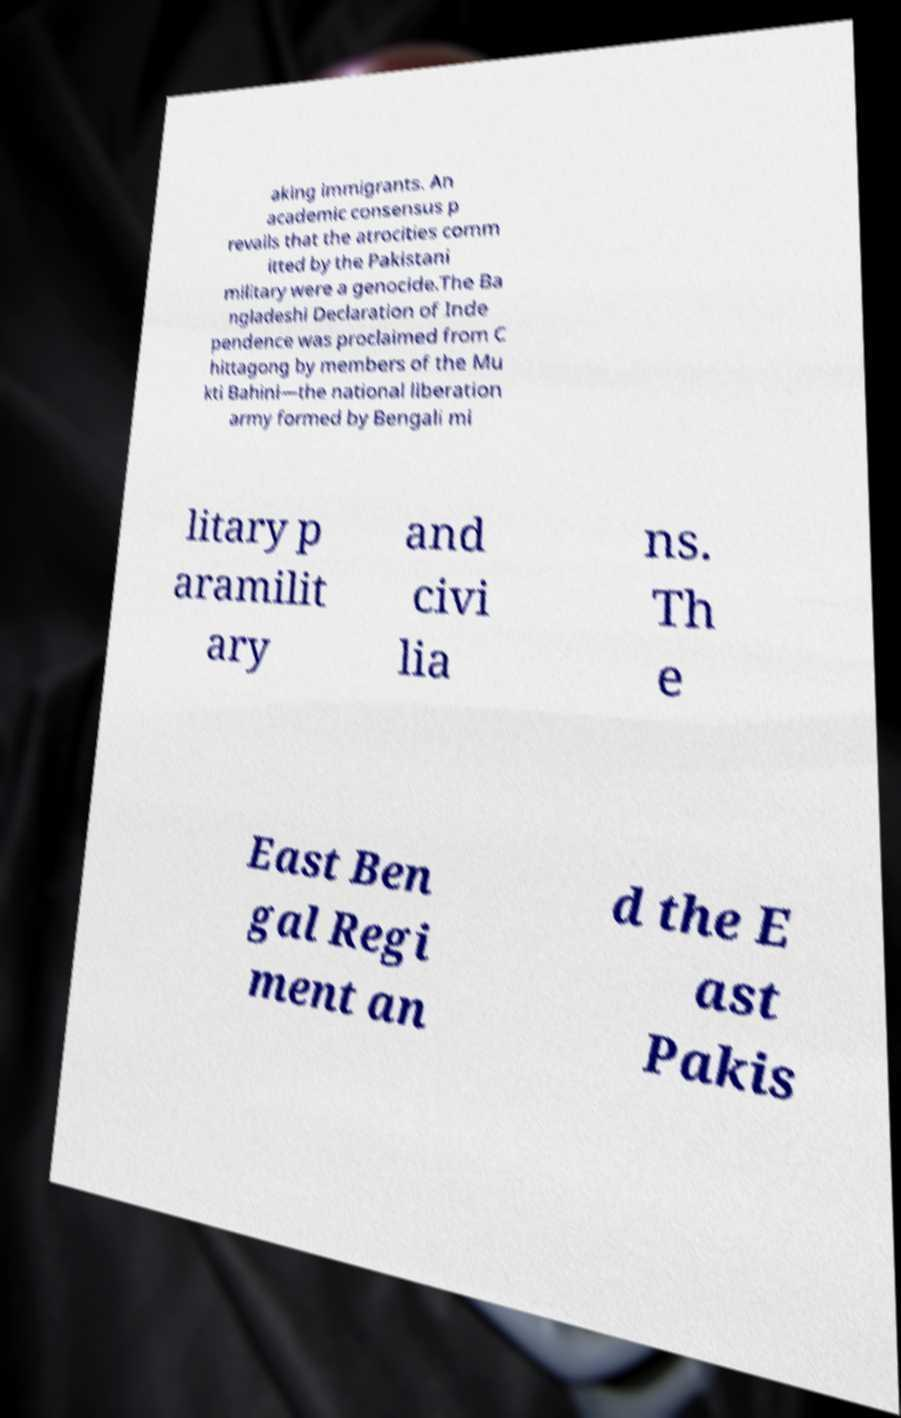Please identify and transcribe the text found in this image. aking immigrants. An academic consensus p revails that the atrocities comm itted by the Pakistani military were a genocide.The Ba ngladeshi Declaration of Inde pendence was proclaimed from C hittagong by members of the Mu kti Bahini—the national liberation army formed by Bengali mi litary p aramilit ary and civi lia ns. Th e East Ben gal Regi ment an d the E ast Pakis 